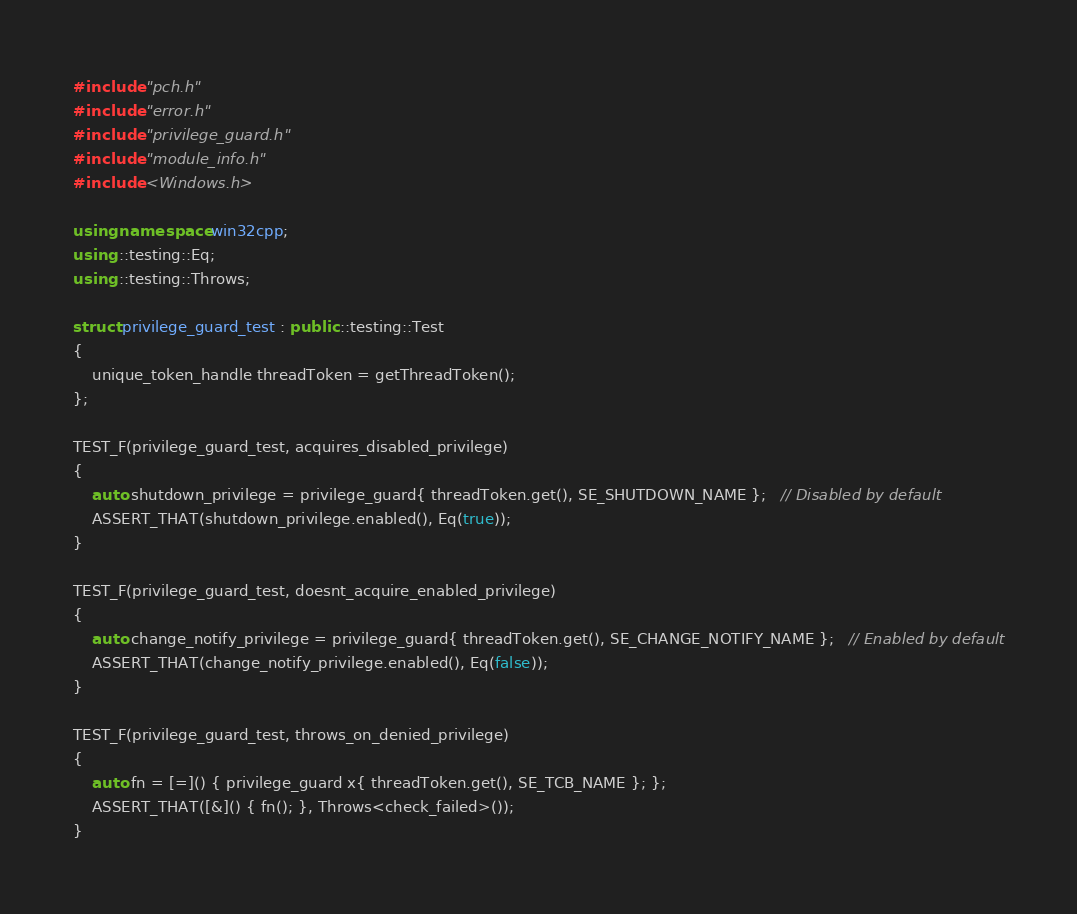Convert code to text. <code><loc_0><loc_0><loc_500><loc_500><_C++_>#include "pch.h"
#include "error.h"
#include "privilege_guard.h"
#include "module_info.h"
#include <Windows.h>

using namespace win32cpp;
using ::testing::Eq;
using ::testing::Throws;

struct privilege_guard_test : public ::testing::Test
{
    unique_token_handle threadToken = getThreadToken();
};

TEST_F(privilege_guard_test, acquires_disabled_privilege)
{
    auto shutdown_privilege = privilege_guard{ threadToken.get(), SE_SHUTDOWN_NAME };   // Disabled by default
    ASSERT_THAT(shutdown_privilege.enabled(), Eq(true));
}

TEST_F(privilege_guard_test, doesnt_acquire_enabled_privilege)
{
    auto change_notify_privilege = privilege_guard{ threadToken.get(), SE_CHANGE_NOTIFY_NAME };   // Enabled by default
    ASSERT_THAT(change_notify_privilege.enabled(), Eq(false));
}

TEST_F(privilege_guard_test, throws_on_denied_privilege)
{
    auto fn = [=]() { privilege_guard x{ threadToken.get(), SE_TCB_NAME }; };
    ASSERT_THAT([&]() { fn(); }, Throws<check_failed>());
}
</code> 